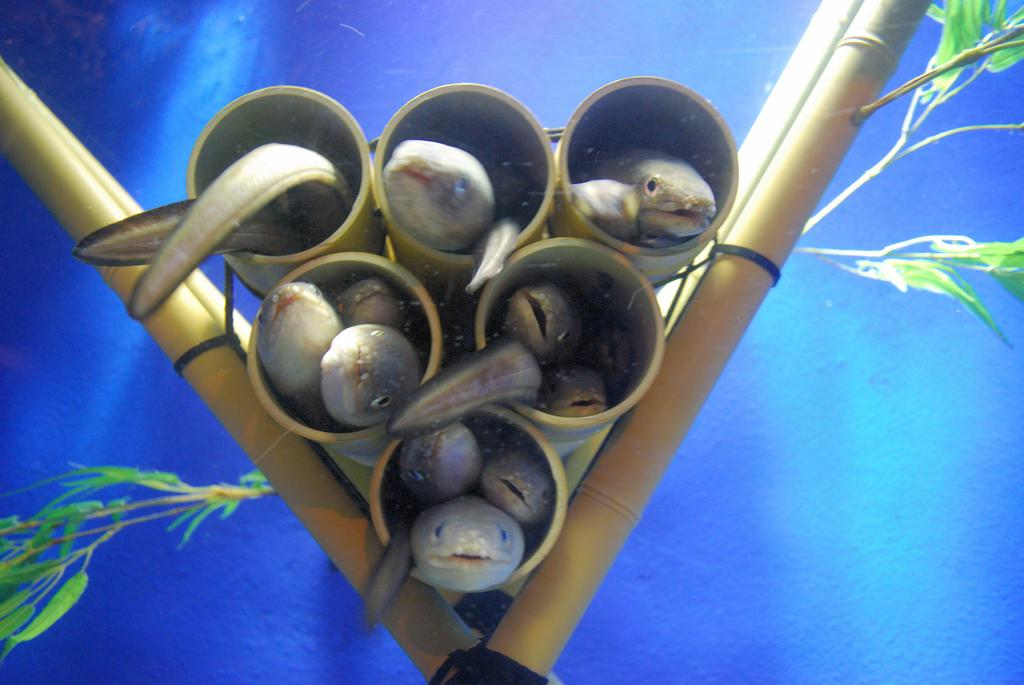What type of animals are in the wooden tubes in the image? There are fishes in wooden tubes in the image. What other objects can be seen in the image? Wooden sticks are visible in the image. What type of vegetation is present in the image? There are plants in the image. What color is the background of the image? The background of the image is blue. What type of fruit is the fishes eating in the image? There is no fruit present in the image, and the fishes are not shown eating anything. 